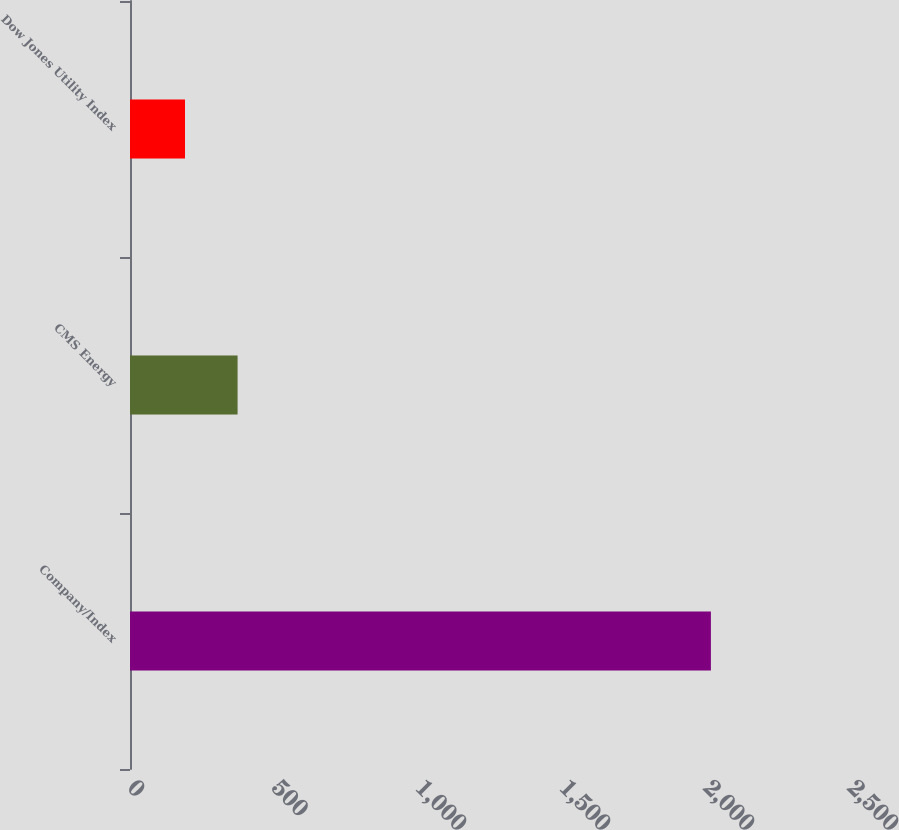Convert chart. <chart><loc_0><loc_0><loc_500><loc_500><bar_chart><fcel>Company/Index<fcel>CMS Energy<fcel>Dow Jones Utility Index<nl><fcel>2017<fcel>373.6<fcel>191<nl></chart> 